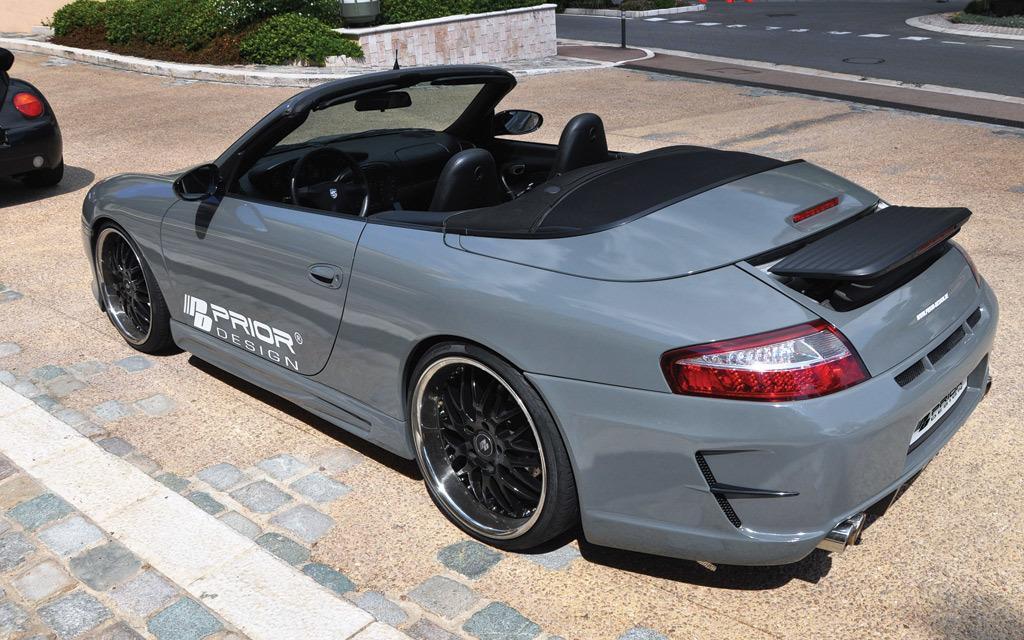Could you give a brief overview of what you see in this image? In this picture we can see a car, on the right side of image we can see road, in the background there are some plants and bushes, the car is of grey color. 